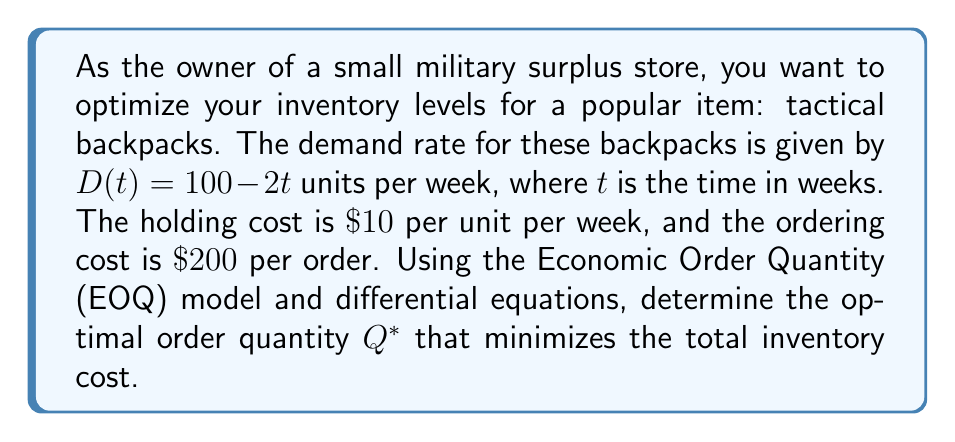Provide a solution to this math problem. To solve this problem, we'll use the EOQ model and differential equations:

1) The total cost function $TC(Q)$ is given by:

   $$TC(Q) = \frac{DS}{Q} + \frac{HQ}{2}$$

   Where:
   $D$ = annual demand
   $S$ = ordering cost per order
   $H$ = holding cost per unit per year
   $Q$ = order quantity

2) To find the average annual demand, we integrate the demand function over a year:

   $$D = \int_0^{52} (100 - 2t) dt = [100t - t^2]_0^{52} = 5200 - 2704 = 2496$$

3) Now we can set up our total cost function:

   $$TC(Q) = \frac{2496 \cdot 200}{Q} + \frac{10Q}{2} = \frac{499200}{Q} + 5Q$$

4) To find the minimum cost, we differentiate $TC(Q)$ with respect to $Q$ and set it to zero:

   $$\frac{d}{dQ}TC(Q) = -\frac{499200}{Q^2} + 5 = 0$$

5) Solving this equation:

   $$\frac{499200}{Q^2} = 5$$
   $$Q^2 = \frac{499200}{5} = 99840$$
   $$Q^* = \sqrt{99840} \approx 316$$

6) To verify this is a minimum, we can check the second derivative is positive:

   $$\frac{d^2}{dQ^2}TC(Q) = \frac{2 \cdot 499200}{Q^3} > 0$$

   This is always positive for $Q > 0$, confirming we've found a minimum.
Answer: $Q^* \approx 316$ backpacks 